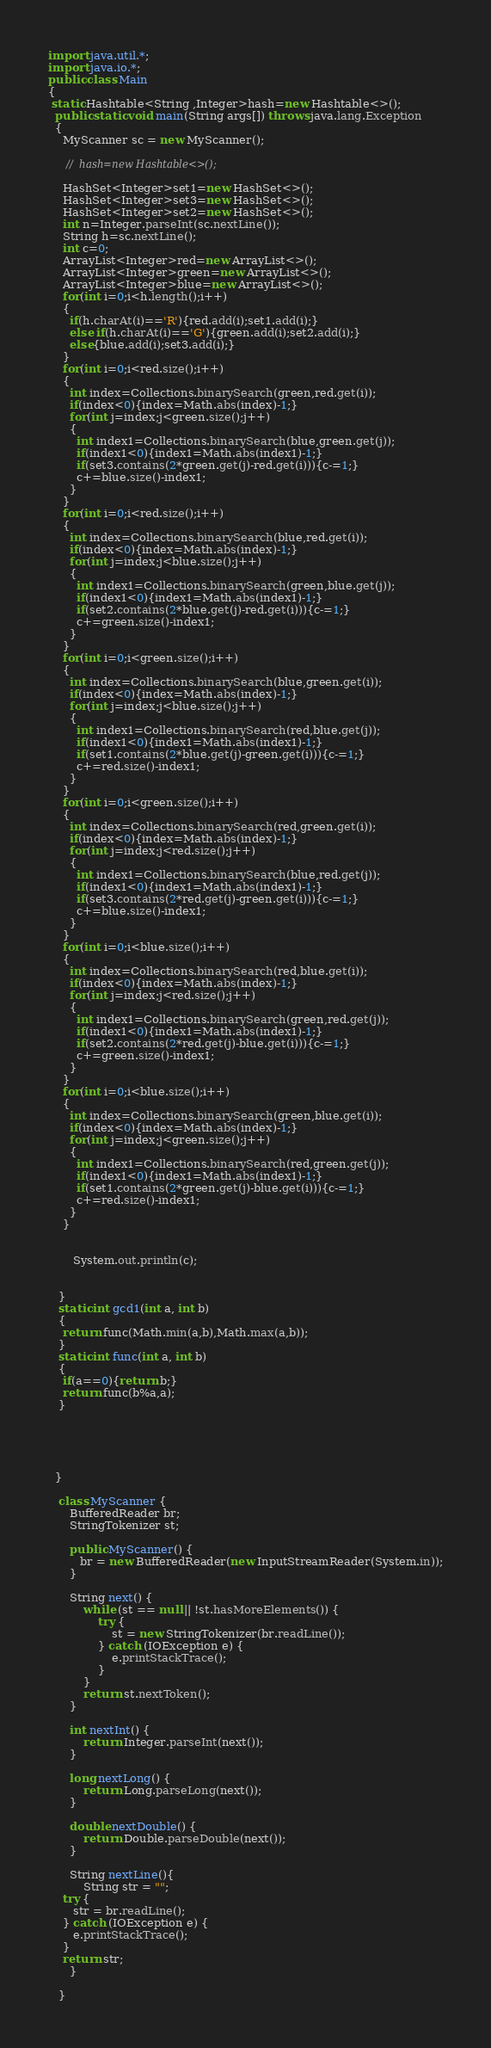Convert code to text. <code><loc_0><loc_0><loc_500><loc_500><_Java_>import java.util.*;
import java.io.*;
public class Main
{
 static Hashtable<String ,Integer>hash=new Hashtable<>();
  public static void main(String args[]) throws java.lang.Exception
  {
    MyScanner sc = new MyScanner();
  
     //  hash=new Hashtable<>();

    HashSet<Integer>set1=new HashSet<>();
    HashSet<Integer>set3=new HashSet<>();
    HashSet<Integer>set2=new HashSet<>();
    int n=Integer.parseInt(sc.nextLine());
    String h=sc.nextLine();
    int c=0;
    ArrayList<Integer>red=new ArrayList<>();
    ArrayList<Integer>green=new ArrayList<>();
    ArrayList<Integer>blue=new ArrayList<>();
    for(int i=0;i<h.length();i++)
    {
      if(h.charAt(i)=='R'){red.add(i);set1.add(i);}
      else if(h.charAt(i)=='G'){green.add(i);set2.add(i);}
      else{blue.add(i);set3.add(i);}
    }
    for(int i=0;i<red.size();i++)
    {
      int index=Collections.binarySearch(green,red.get(i));
      if(index<0){index=Math.abs(index)-1;}
      for(int j=index;j<green.size();j++)
      {
        int index1=Collections.binarySearch(blue,green.get(j));
        if(index1<0){index1=Math.abs(index1)-1;}
        if(set3.contains(2*green.get(j)-red.get(i))){c-=1;}
        c+=blue.size()-index1;
      }
    }
    for(int i=0;i<red.size();i++)
    {
      int index=Collections.binarySearch(blue,red.get(i));
      if(index<0){index=Math.abs(index)-1;}
      for(int j=index;j<blue.size();j++)
      {
        int index1=Collections.binarySearch(green,blue.get(j));
        if(index1<0){index1=Math.abs(index1)-1;}
        if(set2.contains(2*blue.get(j)-red.get(i))){c-=1;}
        c+=green.size()-index1;
      }
    }
    for(int i=0;i<green.size();i++)
    {
      int index=Collections.binarySearch(blue,green.get(i));
      if(index<0){index=Math.abs(index)-1;}
      for(int j=index;j<blue.size();j++)
      {
        int index1=Collections.binarySearch(red,blue.get(j));
        if(index1<0){index1=Math.abs(index1)-1;}
        if(set1.contains(2*blue.get(j)-green.get(i))){c-=1;}
        c+=red.size()-index1;
      }
    }
    for(int i=0;i<green.size();i++)
    {
      int index=Collections.binarySearch(red,green.get(i));
      if(index<0){index=Math.abs(index)-1;}
      for(int j=index;j<red.size();j++)
      {
        int index1=Collections.binarySearch(blue,red.get(j));
        if(index1<0){index1=Math.abs(index1)-1;}
        if(set3.contains(2*red.get(j)-green.get(i))){c-=1;}
        c+=blue.size()-index1;
      }
    }
    for(int i=0;i<blue.size();i++)
    {
      int index=Collections.binarySearch(red,blue.get(i));
      if(index<0){index=Math.abs(index)-1;}
      for(int j=index;j<red.size();j++)
      {
        int index1=Collections.binarySearch(green,red.get(j));
        if(index1<0){index1=Math.abs(index1)-1;}
        if(set2.contains(2*red.get(j)-blue.get(i))){c-=1;}
        c+=green.size()-index1;
      }
    }
    for(int i=0;i<blue.size();i++)
    {
      int index=Collections.binarySearch(green,blue.get(i));
      if(index<0){index=Math.abs(index)-1;}
      for(int j=index;j<green.size();j++)
      {
        int index1=Collections.binarySearch(red,green.get(j));
        if(index1<0){index1=Math.abs(index1)-1;}
        if(set1.contains(2*green.get(j)-blue.get(i))){c-=1;}
        c+=red.size()-index1;
      }
    }


       System.out.println(c);
    
     
   }
   static int gcd1(int a, int b)
   {
    return func(Math.min(a,b),Math.max(a,b));
   }
   static int func(int a, int b)
   {
    if(a==0){return b;}
    return func(b%a,a);
   }
     
  
  

  
  }

   class MyScanner {
      BufferedReader br;
      StringTokenizer st;
 
      public MyScanner() {
         br = new BufferedReader(new InputStreamReader(System.in));
      }
 
      String next() {
          while (st == null || !st.hasMoreElements()) {
              try {
                  st = new StringTokenizer(br.readLine());
              } catch (IOException e) {
                  e.printStackTrace();
              }
          }
          return st.nextToken();
      }
 
      int nextInt() {
          return Integer.parseInt(next());
      }
 
      long nextLong() {
          return Long.parseLong(next());
      }
 
      double nextDouble() {
          return Double.parseDouble(next());
      }
 
      String nextLine(){
          String str = "";
    try {
       str = br.readLine();
    } catch (IOException e) {
       e.printStackTrace();
    }
    return str;
      }
 
   }</code> 